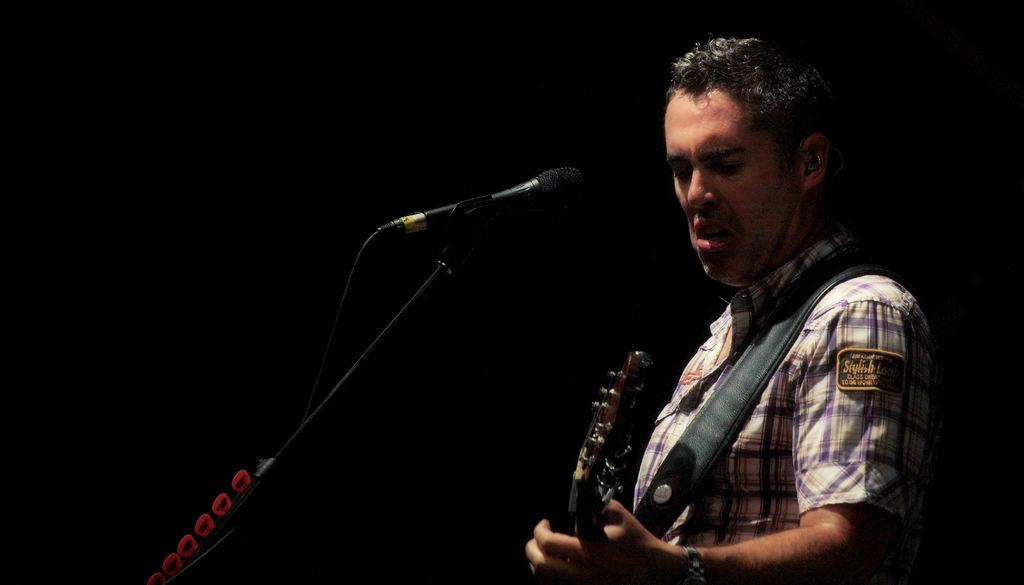What is the man in the image holding? The man is holding a guitar. Where is the guitar located in relation to the man? The guitar is in the man's hand. What can be seen on the left side of the image? There is a microphone stand on the left side of the image. What is the color of the background in the image? The background of the image is black. Can you tell me how much the man paid for the island in the image? There is no island present in the image, and therefore no payment can be associated with it. 